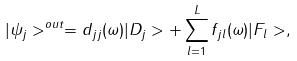<formula> <loc_0><loc_0><loc_500><loc_500>| \psi _ { j } > ^ { o u t } = d _ { j j } ( \omega ) | D _ { j } > + \sum _ { l = 1 } ^ { L } f _ { j l } ( \omega ) | F _ { l } > ,</formula> 